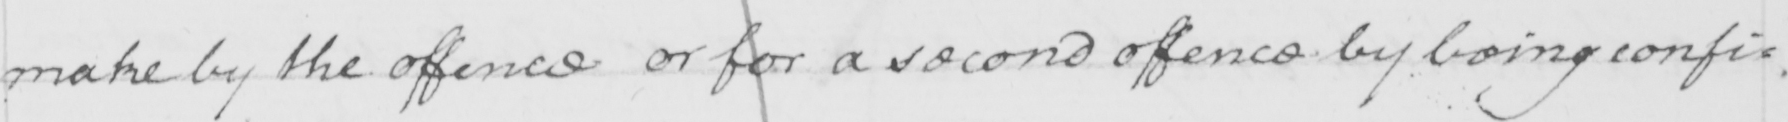Can you tell me what this handwritten text says? make by the offence or for a second offence by being confi : 